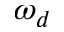<formula> <loc_0><loc_0><loc_500><loc_500>\omega _ { d }</formula> 